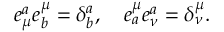Convert formula to latex. <formula><loc_0><loc_0><loc_500><loc_500>e _ { \mu } ^ { a } e _ { b } ^ { \mu } = \delta _ { b } ^ { a } , \quad e _ { a } ^ { \mu } e _ { \nu } ^ { a } = \delta _ { \nu } ^ { \mu } .</formula> 